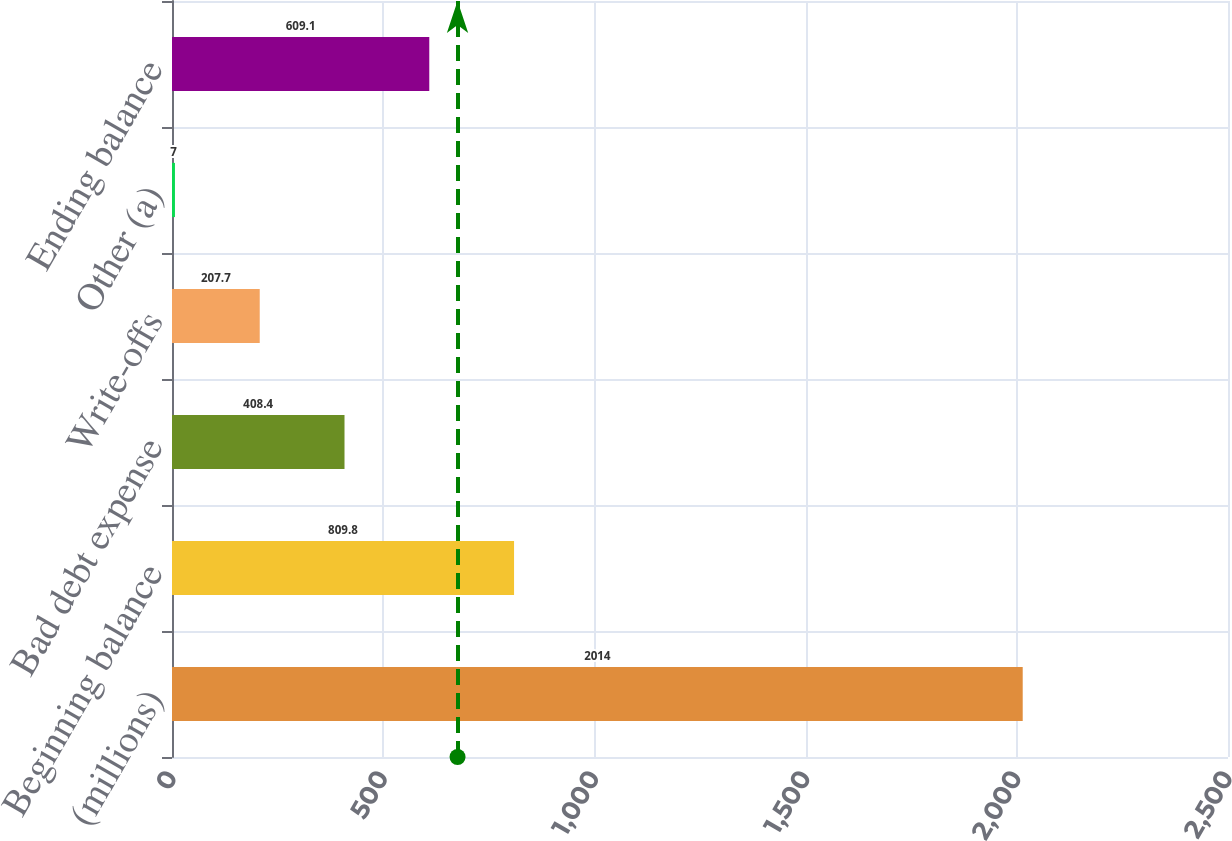<chart> <loc_0><loc_0><loc_500><loc_500><bar_chart><fcel>(millions)<fcel>Beginning balance<fcel>Bad debt expense<fcel>Write-offs<fcel>Other (a)<fcel>Ending balance<nl><fcel>2014<fcel>809.8<fcel>408.4<fcel>207.7<fcel>7<fcel>609.1<nl></chart> 